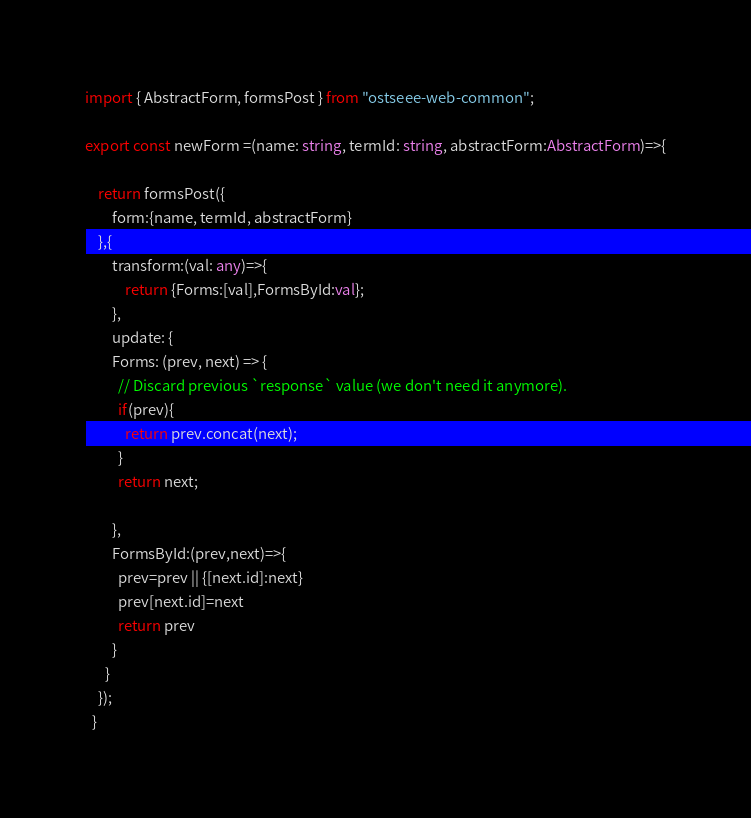Convert code to text. <code><loc_0><loc_0><loc_500><loc_500><_TypeScript_>import { AbstractForm, formsPost } from "ostseee-web-common";

export const newForm =(name: string, termId: string, abstractForm:AbstractForm)=>{
  
    return formsPost({
        form:{name, termId, abstractForm}
    },{
        transform:(val: any)=>{
            return {Forms:[val],FormsById:val};
        },
        update: {
        Forms: (prev, next) => {
          // Discard previous `response` value (we don't need it anymore).
          if(prev){
            return prev.concat(next);
          }
          return next;
          
        },
        FormsById:(prev,next)=>{
          prev=prev || {[next.id]:next}
          prev[next.id]=next
          return prev
        }
      }
    });
  }</code> 